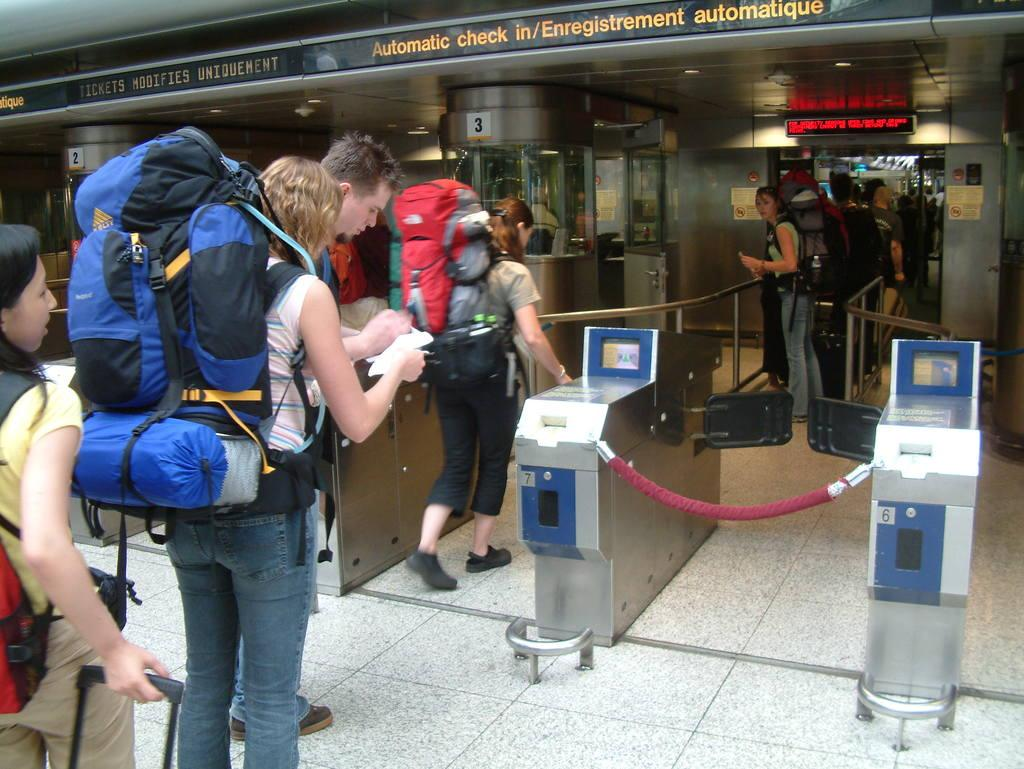What is the setting of the image? The image is taken at a checkpoint. Where are the people located in the image? The people are in the middle and left side of the image. What are the people holding in the image? The people are holding bags. What else are the people wearing in the image? The people are wearing backpacks. What type of zebra can be seen in the image? There is no zebra present in the image. How many light bulbs are visible in the image? There are no light bulbs visible in the image. 